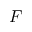<formula> <loc_0><loc_0><loc_500><loc_500>F</formula> 